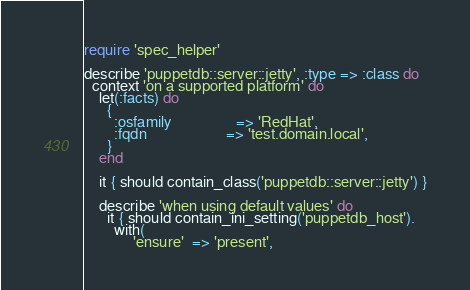Convert code to text. <code><loc_0><loc_0><loc_500><loc_500><_Ruby_>require 'spec_helper'

describe 'puppetdb::server::jetty', :type => :class do
  context 'on a supported platform' do
    let(:facts) do
      {
        :osfamily                 => 'RedHat',
        :fqdn                     => 'test.domain.local',
      }
    end

    it { should contain_class('puppetdb::server::jetty') }

    describe 'when using default values' do
      it { should contain_ini_setting('puppetdb_host').
        with(
             'ensure'  => 'present',</code> 